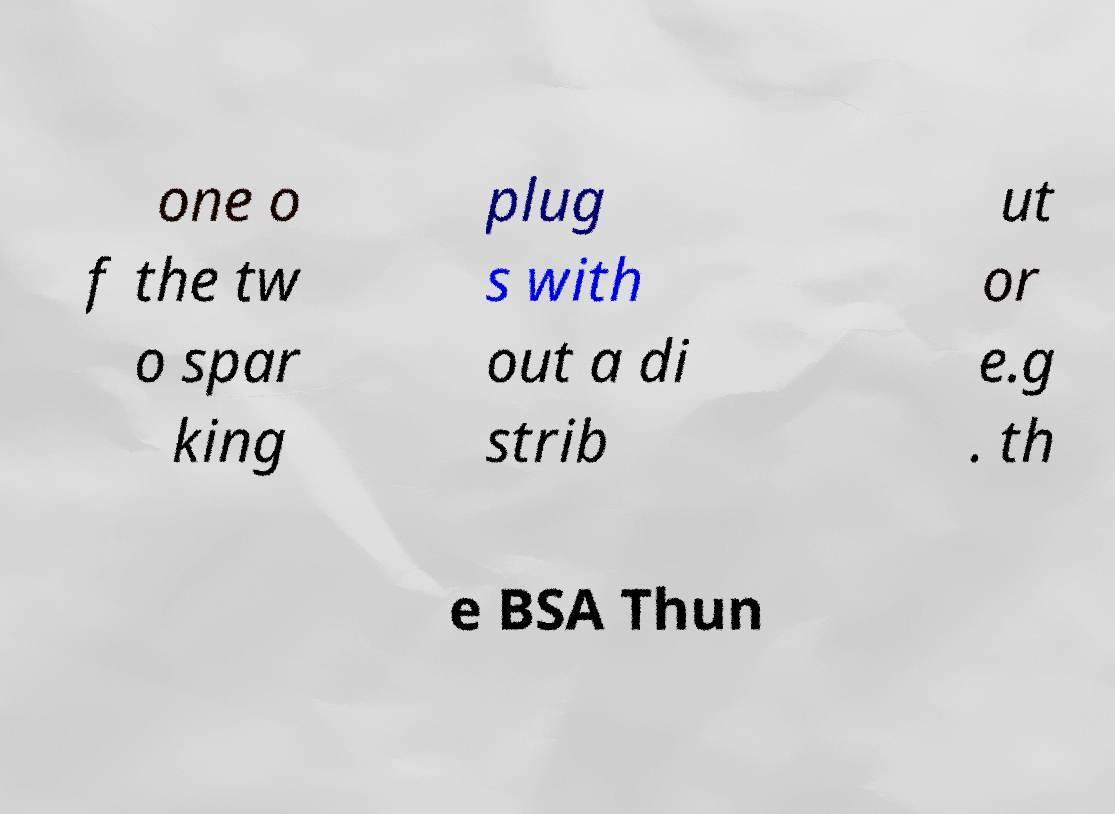Can you accurately transcribe the text from the provided image for me? one o f the tw o spar king plug s with out a di strib ut or e.g . th e BSA Thun 